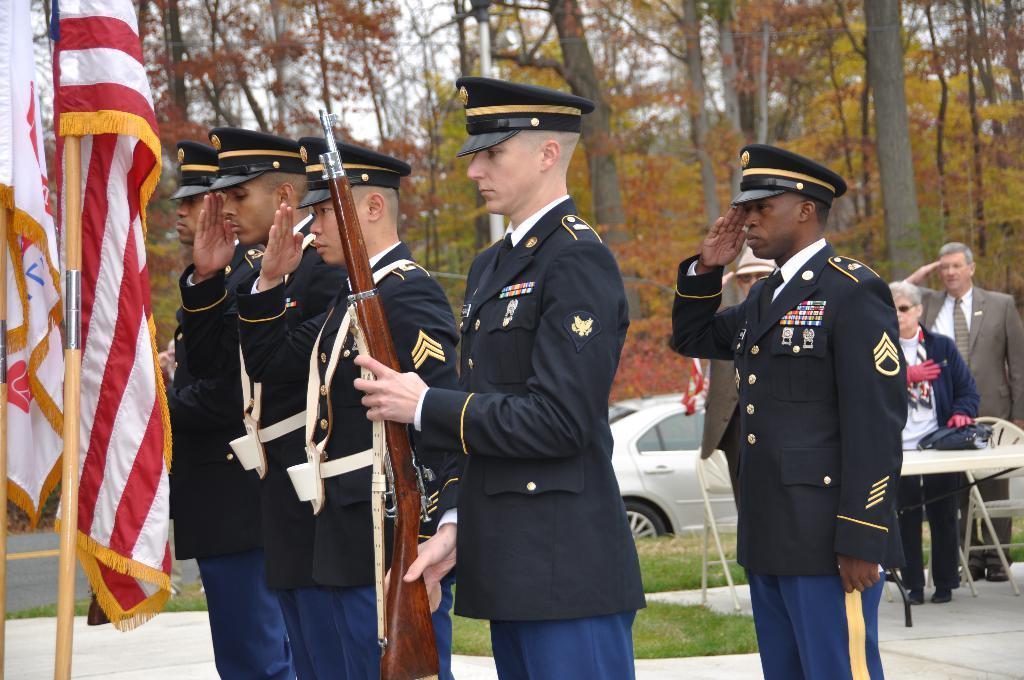Describe this image in one or two sentences. In this image we can see there are persons standing and holding a gun. In front there are flags. At the back there is a table, chair, and a bag. And there is a car on the road. And there are trees, grass and a sky. 